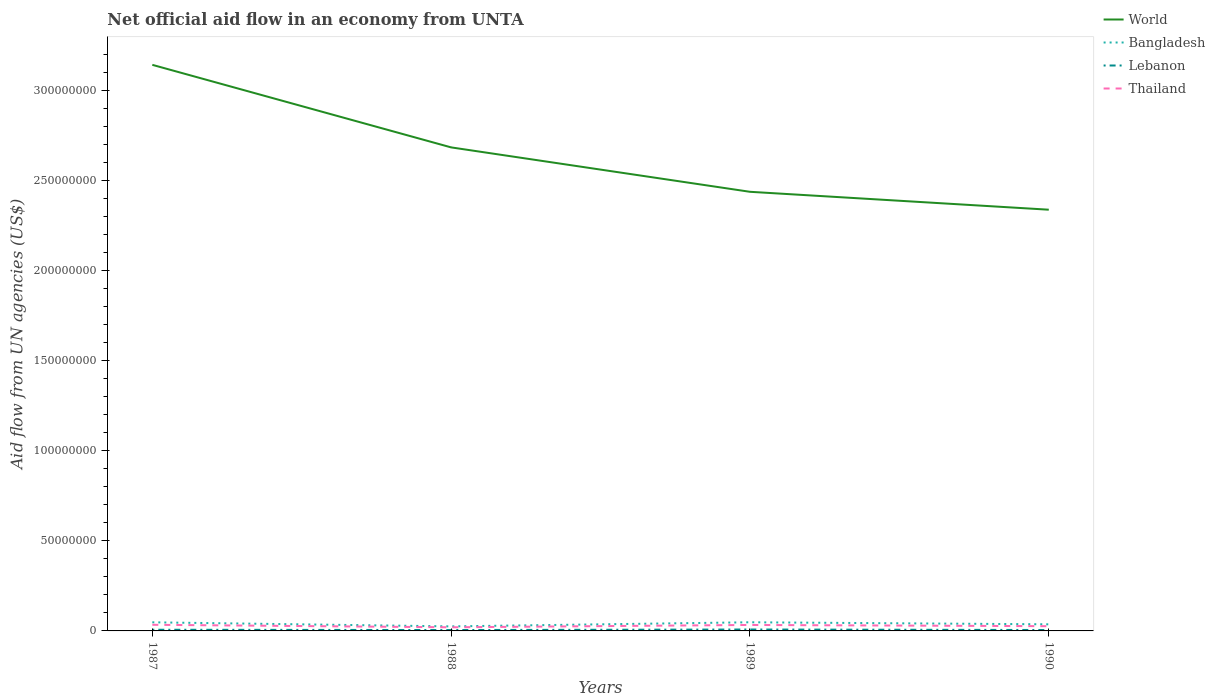How many different coloured lines are there?
Offer a terse response. 4. Does the line corresponding to World intersect with the line corresponding to Lebanon?
Provide a succinct answer. No. Across all years, what is the maximum net official aid flow in World?
Your response must be concise. 2.34e+08. What is the total net official aid flow in Thailand in the graph?
Make the answer very short. 1.39e+06. What is the difference between the highest and the second highest net official aid flow in Bangladesh?
Offer a terse response. 2.28e+06. How many years are there in the graph?
Your answer should be very brief. 4. What is the difference between two consecutive major ticks on the Y-axis?
Provide a short and direct response. 5.00e+07. Are the values on the major ticks of Y-axis written in scientific E-notation?
Provide a short and direct response. No. How are the legend labels stacked?
Ensure brevity in your answer.  Vertical. What is the title of the graph?
Your response must be concise. Net official aid flow in an economy from UNTA. Does "St. Kitts and Nevis" appear as one of the legend labels in the graph?
Offer a terse response. No. What is the label or title of the X-axis?
Make the answer very short. Years. What is the label or title of the Y-axis?
Your answer should be compact. Aid flow from UN agencies (US$). What is the Aid flow from UN agencies (US$) in World in 1987?
Your answer should be compact. 3.14e+08. What is the Aid flow from UN agencies (US$) in Bangladesh in 1987?
Offer a very short reply. 4.78e+06. What is the Aid flow from UN agencies (US$) in Lebanon in 1987?
Offer a very short reply. 6.50e+05. What is the Aid flow from UN agencies (US$) of Thailand in 1987?
Offer a terse response. 3.40e+06. What is the Aid flow from UN agencies (US$) in World in 1988?
Offer a terse response. 2.68e+08. What is the Aid flow from UN agencies (US$) of Bangladesh in 1988?
Ensure brevity in your answer.  2.52e+06. What is the Aid flow from UN agencies (US$) in Lebanon in 1988?
Provide a short and direct response. 4.90e+05. What is the Aid flow from UN agencies (US$) of Thailand in 1988?
Provide a succinct answer. 2.01e+06. What is the Aid flow from UN agencies (US$) of World in 1989?
Your answer should be very brief. 2.44e+08. What is the Aid flow from UN agencies (US$) of Bangladesh in 1989?
Ensure brevity in your answer.  4.80e+06. What is the Aid flow from UN agencies (US$) of Lebanon in 1989?
Offer a terse response. 7.90e+05. What is the Aid flow from UN agencies (US$) in Thailand in 1989?
Ensure brevity in your answer.  3.31e+06. What is the Aid flow from UN agencies (US$) in World in 1990?
Offer a very short reply. 2.34e+08. What is the Aid flow from UN agencies (US$) of Bangladesh in 1990?
Make the answer very short. 3.67e+06. What is the Aid flow from UN agencies (US$) of Lebanon in 1990?
Your answer should be compact. 5.10e+05. What is the Aid flow from UN agencies (US$) of Thailand in 1990?
Offer a very short reply. 2.63e+06. Across all years, what is the maximum Aid flow from UN agencies (US$) of World?
Ensure brevity in your answer.  3.14e+08. Across all years, what is the maximum Aid flow from UN agencies (US$) in Bangladesh?
Keep it short and to the point. 4.80e+06. Across all years, what is the maximum Aid flow from UN agencies (US$) in Lebanon?
Ensure brevity in your answer.  7.90e+05. Across all years, what is the maximum Aid flow from UN agencies (US$) in Thailand?
Make the answer very short. 3.40e+06. Across all years, what is the minimum Aid flow from UN agencies (US$) in World?
Provide a succinct answer. 2.34e+08. Across all years, what is the minimum Aid flow from UN agencies (US$) in Bangladesh?
Your response must be concise. 2.52e+06. Across all years, what is the minimum Aid flow from UN agencies (US$) in Thailand?
Give a very brief answer. 2.01e+06. What is the total Aid flow from UN agencies (US$) of World in the graph?
Give a very brief answer. 1.06e+09. What is the total Aid flow from UN agencies (US$) in Bangladesh in the graph?
Keep it short and to the point. 1.58e+07. What is the total Aid flow from UN agencies (US$) in Lebanon in the graph?
Provide a short and direct response. 2.44e+06. What is the total Aid flow from UN agencies (US$) in Thailand in the graph?
Offer a terse response. 1.14e+07. What is the difference between the Aid flow from UN agencies (US$) in World in 1987 and that in 1988?
Make the answer very short. 4.58e+07. What is the difference between the Aid flow from UN agencies (US$) in Bangladesh in 1987 and that in 1988?
Your answer should be compact. 2.26e+06. What is the difference between the Aid flow from UN agencies (US$) of Lebanon in 1987 and that in 1988?
Give a very brief answer. 1.60e+05. What is the difference between the Aid flow from UN agencies (US$) in Thailand in 1987 and that in 1988?
Your answer should be compact. 1.39e+06. What is the difference between the Aid flow from UN agencies (US$) of World in 1987 and that in 1989?
Keep it short and to the point. 7.05e+07. What is the difference between the Aid flow from UN agencies (US$) in Bangladesh in 1987 and that in 1989?
Make the answer very short. -2.00e+04. What is the difference between the Aid flow from UN agencies (US$) in Lebanon in 1987 and that in 1989?
Make the answer very short. -1.40e+05. What is the difference between the Aid flow from UN agencies (US$) in World in 1987 and that in 1990?
Make the answer very short. 8.04e+07. What is the difference between the Aid flow from UN agencies (US$) in Bangladesh in 1987 and that in 1990?
Provide a short and direct response. 1.11e+06. What is the difference between the Aid flow from UN agencies (US$) of Thailand in 1987 and that in 1990?
Your response must be concise. 7.70e+05. What is the difference between the Aid flow from UN agencies (US$) in World in 1988 and that in 1989?
Give a very brief answer. 2.46e+07. What is the difference between the Aid flow from UN agencies (US$) of Bangladesh in 1988 and that in 1989?
Give a very brief answer. -2.28e+06. What is the difference between the Aid flow from UN agencies (US$) in Lebanon in 1988 and that in 1989?
Make the answer very short. -3.00e+05. What is the difference between the Aid flow from UN agencies (US$) in Thailand in 1988 and that in 1989?
Ensure brevity in your answer.  -1.30e+06. What is the difference between the Aid flow from UN agencies (US$) of World in 1988 and that in 1990?
Provide a short and direct response. 3.46e+07. What is the difference between the Aid flow from UN agencies (US$) of Bangladesh in 1988 and that in 1990?
Offer a very short reply. -1.15e+06. What is the difference between the Aid flow from UN agencies (US$) in Lebanon in 1988 and that in 1990?
Offer a very short reply. -2.00e+04. What is the difference between the Aid flow from UN agencies (US$) in Thailand in 1988 and that in 1990?
Your response must be concise. -6.20e+05. What is the difference between the Aid flow from UN agencies (US$) in World in 1989 and that in 1990?
Your answer should be very brief. 9.94e+06. What is the difference between the Aid flow from UN agencies (US$) in Bangladesh in 1989 and that in 1990?
Offer a very short reply. 1.13e+06. What is the difference between the Aid flow from UN agencies (US$) of Thailand in 1989 and that in 1990?
Give a very brief answer. 6.80e+05. What is the difference between the Aid flow from UN agencies (US$) of World in 1987 and the Aid flow from UN agencies (US$) of Bangladesh in 1988?
Your answer should be compact. 3.12e+08. What is the difference between the Aid flow from UN agencies (US$) in World in 1987 and the Aid flow from UN agencies (US$) in Lebanon in 1988?
Provide a succinct answer. 3.14e+08. What is the difference between the Aid flow from UN agencies (US$) in World in 1987 and the Aid flow from UN agencies (US$) in Thailand in 1988?
Your answer should be compact. 3.12e+08. What is the difference between the Aid flow from UN agencies (US$) of Bangladesh in 1987 and the Aid flow from UN agencies (US$) of Lebanon in 1988?
Give a very brief answer. 4.29e+06. What is the difference between the Aid flow from UN agencies (US$) of Bangladesh in 1987 and the Aid flow from UN agencies (US$) of Thailand in 1988?
Make the answer very short. 2.77e+06. What is the difference between the Aid flow from UN agencies (US$) in Lebanon in 1987 and the Aid flow from UN agencies (US$) in Thailand in 1988?
Your answer should be very brief. -1.36e+06. What is the difference between the Aid flow from UN agencies (US$) in World in 1987 and the Aid flow from UN agencies (US$) in Bangladesh in 1989?
Keep it short and to the point. 3.09e+08. What is the difference between the Aid flow from UN agencies (US$) of World in 1987 and the Aid flow from UN agencies (US$) of Lebanon in 1989?
Give a very brief answer. 3.13e+08. What is the difference between the Aid flow from UN agencies (US$) of World in 1987 and the Aid flow from UN agencies (US$) of Thailand in 1989?
Offer a very short reply. 3.11e+08. What is the difference between the Aid flow from UN agencies (US$) in Bangladesh in 1987 and the Aid flow from UN agencies (US$) in Lebanon in 1989?
Give a very brief answer. 3.99e+06. What is the difference between the Aid flow from UN agencies (US$) in Bangladesh in 1987 and the Aid flow from UN agencies (US$) in Thailand in 1989?
Your answer should be very brief. 1.47e+06. What is the difference between the Aid flow from UN agencies (US$) in Lebanon in 1987 and the Aid flow from UN agencies (US$) in Thailand in 1989?
Offer a very short reply. -2.66e+06. What is the difference between the Aid flow from UN agencies (US$) of World in 1987 and the Aid flow from UN agencies (US$) of Bangladesh in 1990?
Provide a short and direct response. 3.11e+08. What is the difference between the Aid flow from UN agencies (US$) in World in 1987 and the Aid flow from UN agencies (US$) in Lebanon in 1990?
Your answer should be compact. 3.14e+08. What is the difference between the Aid flow from UN agencies (US$) of World in 1987 and the Aid flow from UN agencies (US$) of Thailand in 1990?
Provide a succinct answer. 3.12e+08. What is the difference between the Aid flow from UN agencies (US$) in Bangladesh in 1987 and the Aid flow from UN agencies (US$) in Lebanon in 1990?
Your response must be concise. 4.27e+06. What is the difference between the Aid flow from UN agencies (US$) in Bangladesh in 1987 and the Aid flow from UN agencies (US$) in Thailand in 1990?
Your answer should be compact. 2.15e+06. What is the difference between the Aid flow from UN agencies (US$) in Lebanon in 1987 and the Aid flow from UN agencies (US$) in Thailand in 1990?
Your response must be concise. -1.98e+06. What is the difference between the Aid flow from UN agencies (US$) of World in 1988 and the Aid flow from UN agencies (US$) of Bangladesh in 1989?
Provide a short and direct response. 2.64e+08. What is the difference between the Aid flow from UN agencies (US$) of World in 1988 and the Aid flow from UN agencies (US$) of Lebanon in 1989?
Offer a terse response. 2.68e+08. What is the difference between the Aid flow from UN agencies (US$) in World in 1988 and the Aid flow from UN agencies (US$) in Thailand in 1989?
Keep it short and to the point. 2.65e+08. What is the difference between the Aid flow from UN agencies (US$) in Bangladesh in 1988 and the Aid flow from UN agencies (US$) in Lebanon in 1989?
Provide a short and direct response. 1.73e+06. What is the difference between the Aid flow from UN agencies (US$) of Bangladesh in 1988 and the Aid flow from UN agencies (US$) of Thailand in 1989?
Offer a very short reply. -7.90e+05. What is the difference between the Aid flow from UN agencies (US$) of Lebanon in 1988 and the Aid flow from UN agencies (US$) of Thailand in 1989?
Offer a terse response. -2.82e+06. What is the difference between the Aid flow from UN agencies (US$) in World in 1988 and the Aid flow from UN agencies (US$) in Bangladesh in 1990?
Your answer should be compact. 2.65e+08. What is the difference between the Aid flow from UN agencies (US$) of World in 1988 and the Aid flow from UN agencies (US$) of Lebanon in 1990?
Your answer should be compact. 2.68e+08. What is the difference between the Aid flow from UN agencies (US$) of World in 1988 and the Aid flow from UN agencies (US$) of Thailand in 1990?
Provide a succinct answer. 2.66e+08. What is the difference between the Aid flow from UN agencies (US$) of Bangladesh in 1988 and the Aid flow from UN agencies (US$) of Lebanon in 1990?
Give a very brief answer. 2.01e+06. What is the difference between the Aid flow from UN agencies (US$) in Bangladesh in 1988 and the Aid flow from UN agencies (US$) in Thailand in 1990?
Offer a terse response. -1.10e+05. What is the difference between the Aid flow from UN agencies (US$) in Lebanon in 1988 and the Aid flow from UN agencies (US$) in Thailand in 1990?
Make the answer very short. -2.14e+06. What is the difference between the Aid flow from UN agencies (US$) of World in 1989 and the Aid flow from UN agencies (US$) of Bangladesh in 1990?
Offer a terse response. 2.40e+08. What is the difference between the Aid flow from UN agencies (US$) in World in 1989 and the Aid flow from UN agencies (US$) in Lebanon in 1990?
Give a very brief answer. 2.43e+08. What is the difference between the Aid flow from UN agencies (US$) in World in 1989 and the Aid flow from UN agencies (US$) in Thailand in 1990?
Provide a succinct answer. 2.41e+08. What is the difference between the Aid flow from UN agencies (US$) of Bangladesh in 1989 and the Aid flow from UN agencies (US$) of Lebanon in 1990?
Offer a very short reply. 4.29e+06. What is the difference between the Aid flow from UN agencies (US$) of Bangladesh in 1989 and the Aid flow from UN agencies (US$) of Thailand in 1990?
Your response must be concise. 2.17e+06. What is the difference between the Aid flow from UN agencies (US$) of Lebanon in 1989 and the Aid flow from UN agencies (US$) of Thailand in 1990?
Provide a succinct answer. -1.84e+06. What is the average Aid flow from UN agencies (US$) in World per year?
Make the answer very short. 2.65e+08. What is the average Aid flow from UN agencies (US$) in Bangladesh per year?
Offer a very short reply. 3.94e+06. What is the average Aid flow from UN agencies (US$) in Lebanon per year?
Make the answer very short. 6.10e+05. What is the average Aid flow from UN agencies (US$) of Thailand per year?
Your response must be concise. 2.84e+06. In the year 1987, what is the difference between the Aid flow from UN agencies (US$) of World and Aid flow from UN agencies (US$) of Bangladesh?
Give a very brief answer. 3.09e+08. In the year 1987, what is the difference between the Aid flow from UN agencies (US$) of World and Aid flow from UN agencies (US$) of Lebanon?
Ensure brevity in your answer.  3.14e+08. In the year 1987, what is the difference between the Aid flow from UN agencies (US$) of World and Aid flow from UN agencies (US$) of Thailand?
Your response must be concise. 3.11e+08. In the year 1987, what is the difference between the Aid flow from UN agencies (US$) of Bangladesh and Aid flow from UN agencies (US$) of Lebanon?
Offer a very short reply. 4.13e+06. In the year 1987, what is the difference between the Aid flow from UN agencies (US$) of Bangladesh and Aid flow from UN agencies (US$) of Thailand?
Ensure brevity in your answer.  1.38e+06. In the year 1987, what is the difference between the Aid flow from UN agencies (US$) in Lebanon and Aid flow from UN agencies (US$) in Thailand?
Give a very brief answer. -2.75e+06. In the year 1988, what is the difference between the Aid flow from UN agencies (US$) of World and Aid flow from UN agencies (US$) of Bangladesh?
Your answer should be very brief. 2.66e+08. In the year 1988, what is the difference between the Aid flow from UN agencies (US$) in World and Aid flow from UN agencies (US$) in Lebanon?
Give a very brief answer. 2.68e+08. In the year 1988, what is the difference between the Aid flow from UN agencies (US$) in World and Aid flow from UN agencies (US$) in Thailand?
Your response must be concise. 2.66e+08. In the year 1988, what is the difference between the Aid flow from UN agencies (US$) of Bangladesh and Aid flow from UN agencies (US$) of Lebanon?
Make the answer very short. 2.03e+06. In the year 1988, what is the difference between the Aid flow from UN agencies (US$) of Bangladesh and Aid flow from UN agencies (US$) of Thailand?
Your answer should be compact. 5.10e+05. In the year 1988, what is the difference between the Aid flow from UN agencies (US$) of Lebanon and Aid flow from UN agencies (US$) of Thailand?
Provide a succinct answer. -1.52e+06. In the year 1989, what is the difference between the Aid flow from UN agencies (US$) of World and Aid flow from UN agencies (US$) of Bangladesh?
Make the answer very short. 2.39e+08. In the year 1989, what is the difference between the Aid flow from UN agencies (US$) of World and Aid flow from UN agencies (US$) of Lebanon?
Ensure brevity in your answer.  2.43e+08. In the year 1989, what is the difference between the Aid flow from UN agencies (US$) in World and Aid flow from UN agencies (US$) in Thailand?
Your answer should be very brief. 2.40e+08. In the year 1989, what is the difference between the Aid flow from UN agencies (US$) of Bangladesh and Aid flow from UN agencies (US$) of Lebanon?
Make the answer very short. 4.01e+06. In the year 1989, what is the difference between the Aid flow from UN agencies (US$) in Bangladesh and Aid flow from UN agencies (US$) in Thailand?
Provide a short and direct response. 1.49e+06. In the year 1989, what is the difference between the Aid flow from UN agencies (US$) of Lebanon and Aid flow from UN agencies (US$) of Thailand?
Offer a very short reply. -2.52e+06. In the year 1990, what is the difference between the Aid flow from UN agencies (US$) in World and Aid flow from UN agencies (US$) in Bangladesh?
Your answer should be compact. 2.30e+08. In the year 1990, what is the difference between the Aid flow from UN agencies (US$) in World and Aid flow from UN agencies (US$) in Lebanon?
Your answer should be very brief. 2.33e+08. In the year 1990, what is the difference between the Aid flow from UN agencies (US$) of World and Aid flow from UN agencies (US$) of Thailand?
Give a very brief answer. 2.31e+08. In the year 1990, what is the difference between the Aid flow from UN agencies (US$) in Bangladesh and Aid flow from UN agencies (US$) in Lebanon?
Provide a short and direct response. 3.16e+06. In the year 1990, what is the difference between the Aid flow from UN agencies (US$) of Bangladesh and Aid flow from UN agencies (US$) of Thailand?
Keep it short and to the point. 1.04e+06. In the year 1990, what is the difference between the Aid flow from UN agencies (US$) in Lebanon and Aid flow from UN agencies (US$) in Thailand?
Your answer should be very brief. -2.12e+06. What is the ratio of the Aid flow from UN agencies (US$) of World in 1987 to that in 1988?
Provide a succinct answer. 1.17. What is the ratio of the Aid flow from UN agencies (US$) in Bangladesh in 1987 to that in 1988?
Ensure brevity in your answer.  1.9. What is the ratio of the Aid flow from UN agencies (US$) in Lebanon in 1987 to that in 1988?
Provide a succinct answer. 1.33. What is the ratio of the Aid flow from UN agencies (US$) of Thailand in 1987 to that in 1988?
Make the answer very short. 1.69. What is the ratio of the Aid flow from UN agencies (US$) of World in 1987 to that in 1989?
Give a very brief answer. 1.29. What is the ratio of the Aid flow from UN agencies (US$) in Bangladesh in 1987 to that in 1989?
Give a very brief answer. 1. What is the ratio of the Aid flow from UN agencies (US$) in Lebanon in 1987 to that in 1989?
Your answer should be very brief. 0.82. What is the ratio of the Aid flow from UN agencies (US$) in Thailand in 1987 to that in 1989?
Ensure brevity in your answer.  1.03. What is the ratio of the Aid flow from UN agencies (US$) of World in 1987 to that in 1990?
Ensure brevity in your answer.  1.34. What is the ratio of the Aid flow from UN agencies (US$) in Bangladesh in 1987 to that in 1990?
Offer a very short reply. 1.3. What is the ratio of the Aid flow from UN agencies (US$) in Lebanon in 1987 to that in 1990?
Offer a very short reply. 1.27. What is the ratio of the Aid flow from UN agencies (US$) of Thailand in 1987 to that in 1990?
Keep it short and to the point. 1.29. What is the ratio of the Aid flow from UN agencies (US$) of World in 1988 to that in 1989?
Ensure brevity in your answer.  1.1. What is the ratio of the Aid flow from UN agencies (US$) of Bangladesh in 1988 to that in 1989?
Your answer should be very brief. 0.53. What is the ratio of the Aid flow from UN agencies (US$) of Lebanon in 1988 to that in 1989?
Give a very brief answer. 0.62. What is the ratio of the Aid flow from UN agencies (US$) of Thailand in 1988 to that in 1989?
Provide a succinct answer. 0.61. What is the ratio of the Aid flow from UN agencies (US$) of World in 1988 to that in 1990?
Give a very brief answer. 1.15. What is the ratio of the Aid flow from UN agencies (US$) in Bangladesh in 1988 to that in 1990?
Offer a very short reply. 0.69. What is the ratio of the Aid flow from UN agencies (US$) of Lebanon in 1988 to that in 1990?
Give a very brief answer. 0.96. What is the ratio of the Aid flow from UN agencies (US$) of Thailand in 1988 to that in 1990?
Provide a succinct answer. 0.76. What is the ratio of the Aid flow from UN agencies (US$) in World in 1989 to that in 1990?
Keep it short and to the point. 1.04. What is the ratio of the Aid flow from UN agencies (US$) of Bangladesh in 1989 to that in 1990?
Your answer should be compact. 1.31. What is the ratio of the Aid flow from UN agencies (US$) of Lebanon in 1989 to that in 1990?
Your response must be concise. 1.55. What is the ratio of the Aid flow from UN agencies (US$) of Thailand in 1989 to that in 1990?
Offer a very short reply. 1.26. What is the difference between the highest and the second highest Aid flow from UN agencies (US$) of World?
Provide a succinct answer. 4.58e+07. What is the difference between the highest and the second highest Aid flow from UN agencies (US$) in Bangladesh?
Provide a short and direct response. 2.00e+04. What is the difference between the highest and the second highest Aid flow from UN agencies (US$) of Lebanon?
Give a very brief answer. 1.40e+05. What is the difference between the highest and the second highest Aid flow from UN agencies (US$) of Thailand?
Your response must be concise. 9.00e+04. What is the difference between the highest and the lowest Aid flow from UN agencies (US$) of World?
Your answer should be very brief. 8.04e+07. What is the difference between the highest and the lowest Aid flow from UN agencies (US$) of Bangladesh?
Offer a terse response. 2.28e+06. What is the difference between the highest and the lowest Aid flow from UN agencies (US$) of Thailand?
Make the answer very short. 1.39e+06. 